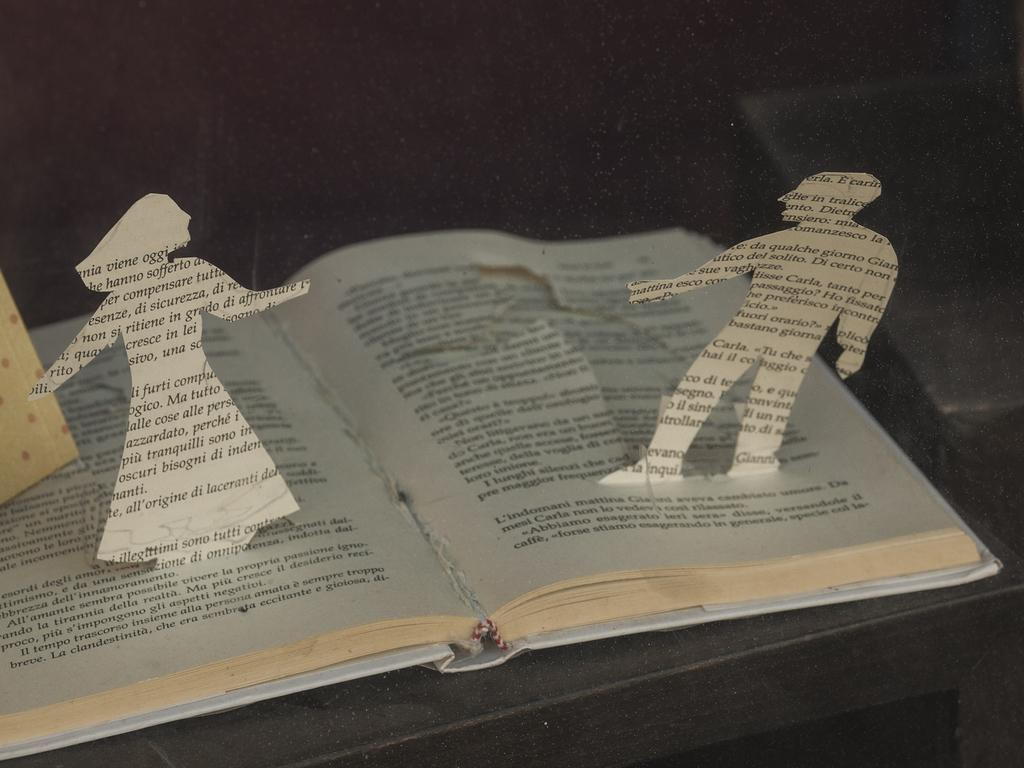<image>
Provide a brief description of the given image. A man's shape cut out of a book page shows the word "in" on his head. 